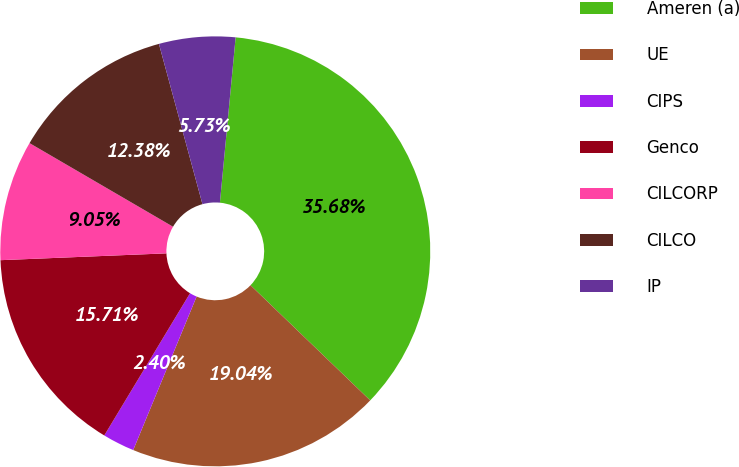Convert chart to OTSL. <chart><loc_0><loc_0><loc_500><loc_500><pie_chart><fcel>Ameren (a)<fcel>UE<fcel>CIPS<fcel>Genco<fcel>CILCORP<fcel>CILCO<fcel>IP<nl><fcel>35.68%<fcel>19.04%<fcel>2.4%<fcel>15.71%<fcel>9.05%<fcel>12.38%<fcel>5.73%<nl></chart> 